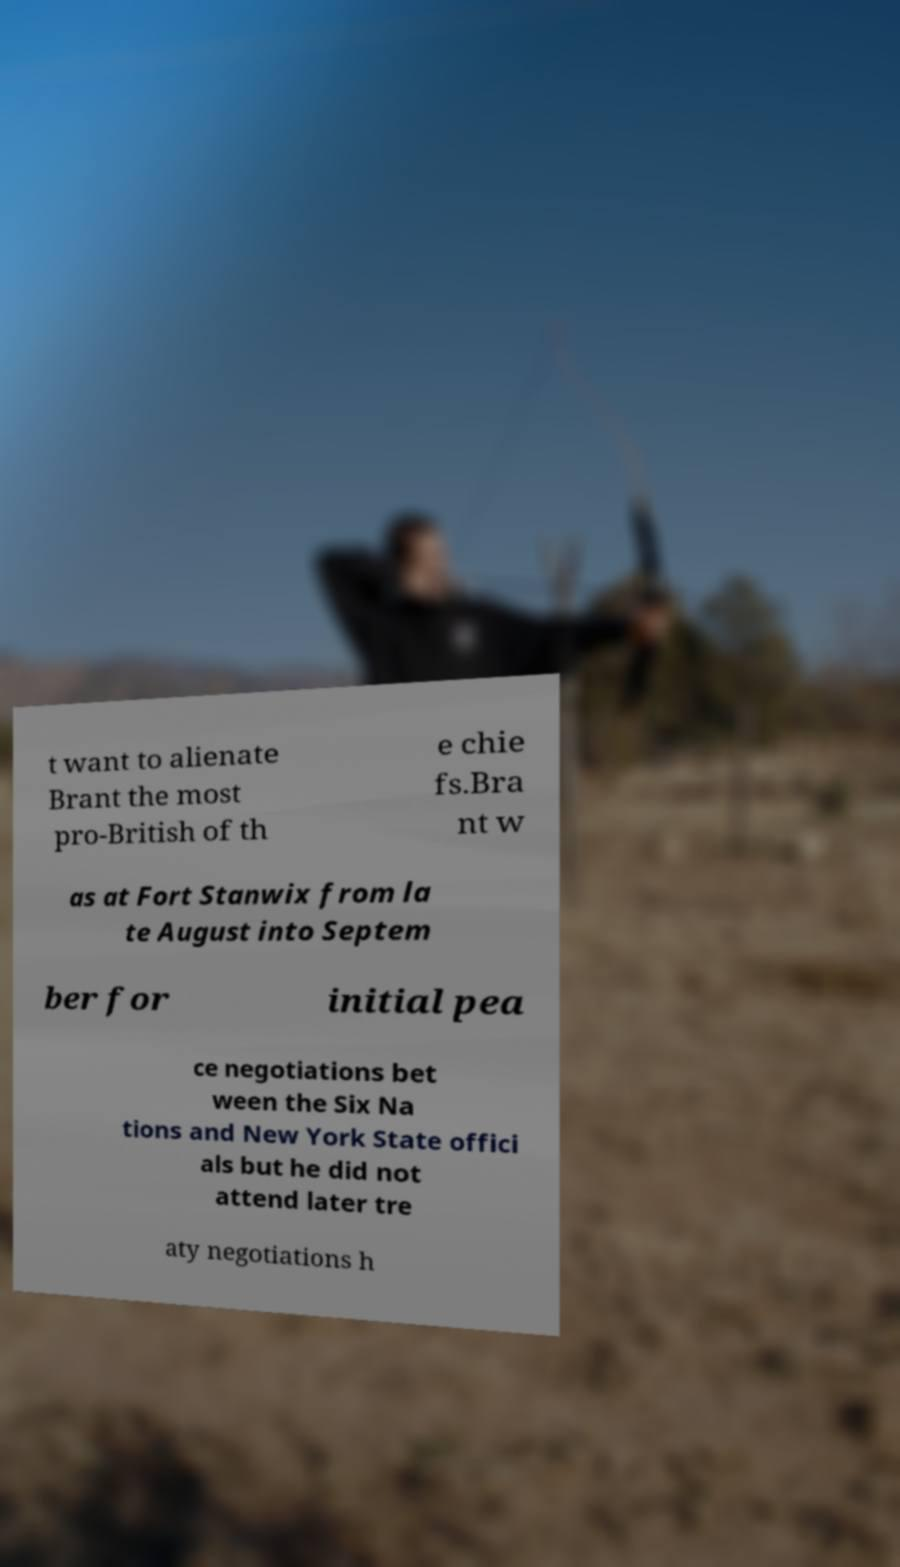Could you assist in decoding the text presented in this image and type it out clearly? t want to alienate Brant the most pro-British of th e chie fs.Bra nt w as at Fort Stanwix from la te August into Septem ber for initial pea ce negotiations bet ween the Six Na tions and New York State offici als but he did not attend later tre aty negotiations h 